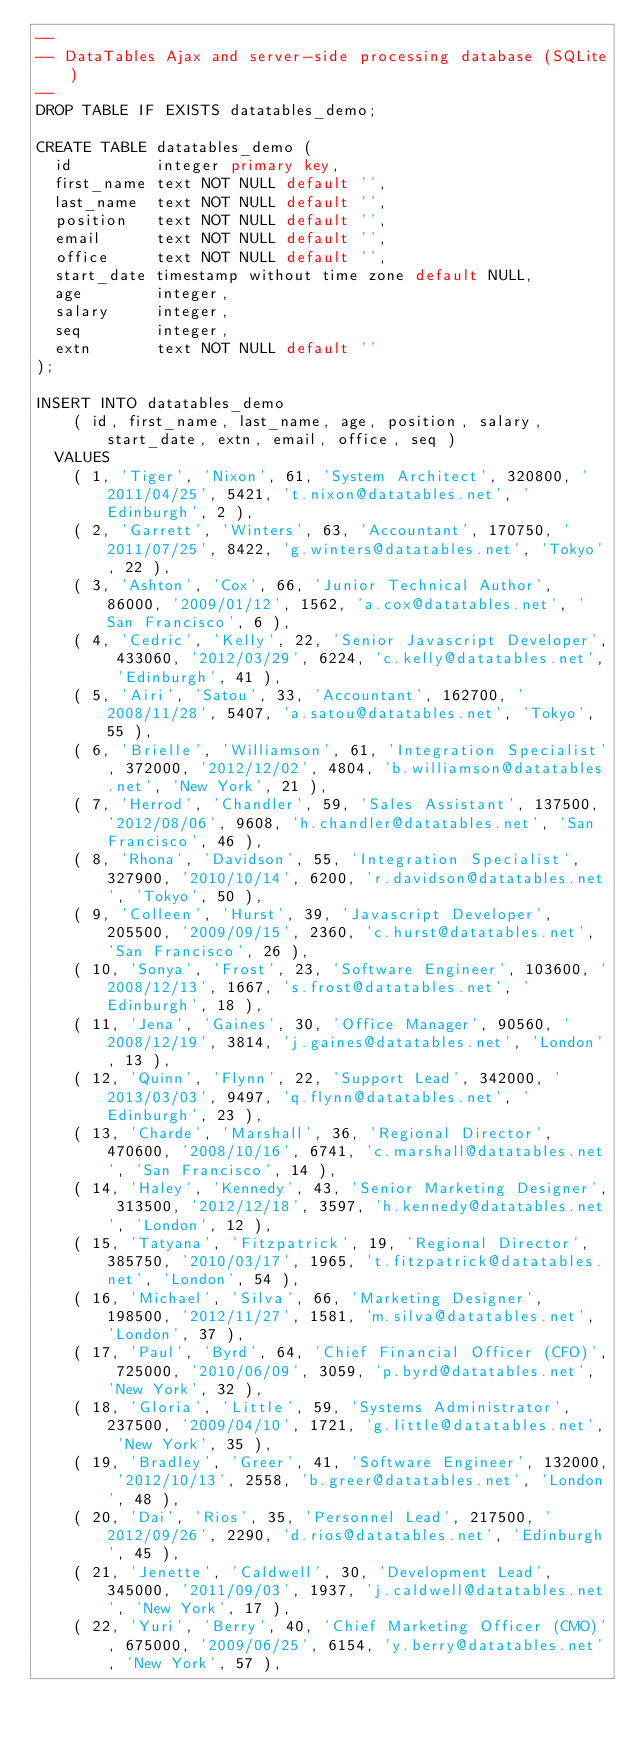<code> <loc_0><loc_0><loc_500><loc_500><_SQL_>--
-- DataTables Ajax and server-side processing database (SQLite)
--
DROP TABLE IF EXISTS datatables_demo;

CREATE TABLE datatables_demo (
	id         integer primary key,
	first_name text NOT NULL default '',
	last_name  text NOT NULL default '',
	position   text NOT NULL default '',
	email      text NOT NULL default '',
	office     text NOT NULL default '',
	start_date timestamp without time zone default NULL,
	age        integer,
	salary     integer,
	seq        integer,
	extn       text NOT NULL default ''
);

INSERT INTO datatables_demo
		( id, first_name, last_name, age, position, salary, start_date, extn, email, office, seq ) 
	VALUES
		( 1, 'Tiger', 'Nixon', 61, 'System Architect', 320800, '2011/04/25', 5421, 't.nixon@datatables.net', 'Edinburgh', 2 ),
		( 2, 'Garrett', 'Winters', 63, 'Accountant', 170750, '2011/07/25', 8422, 'g.winters@datatables.net', 'Tokyo', 22 ),
		( 3, 'Ashton', 'Cox', 66, 'Junior Technical Author', 86000, '2009/01/12', 1562, 'a.cox@datatables.net', 'San Francisco', 6 ),
		( 4, 'Cedric', 'Kelly', 22, 'Senior Javascript Developer', 433060, '2012/03/29', 6224, 'c.kelly@datatables.net', 'Edinburgh', 41 ),
		( 5, 'Airi', 'Satou', 33, 'Accountant', 162700, '2008/11/28', 5407, 'a.satou@datatables.net', 'Tokyo', 55 ),
		( 6, 'Brielle', 'Williamson', 61, 'Integration Specialist', 372000, '2012/12/02', 4804, 'b.williamson@datatables.net', 'New York', 21 ),
		( 7, 'Herrod', 'Chandler', 59, 'Sales Assistant', 137500, '2012/08/06', 9608, 'h.chandler@datatables.net', 'San Francisco', 46 ),
		( 8, 'Rhona', 'Davidson', 55, 'Integration Specialist', 327900, '2010/10/14', 6200, 'r.davidson@datatables.net', 'Tokyo', 50 ),
		( 9, 'Colleen', 'Hurst', 39, 'Javascript Developer', 205500, '2009/09/15', 2360, 'c.hurst@datatables.net', 'San Francisco', 26 ),
		( 10, 'Sonya', 'Frost', 23, 'Software Engineer', 103600, '2008/12/13', 1667, 's.frost@datatables.net', 'Edinburgh', 18 ),
		( 11, 'Jena', 'Gaines', 30, 'Office Manager', 90560, '2008/12/19', 3814, 'j.gaines@datatables.net', 'London', 13 ),
		( 12, 'Quinn', 'Flynn', 22, 'Support Lead', 342000, '2013/03/03', 9497, 'q.flynn@datatables.net', 'Edinburgh', 23 ),
		( 13, 'Charde', 'Marshall', 36, 'Regional Director', 470600, '2008/10/16', 6741, 'c.marshall@datatables.net', 'San Francisco', 14 ),
		( 14, 'Haley', 'Kennedy', 43, 'Senior Marketing Designer', 313500, '2012/12/18', 3597, 'h.kennedy@datatables.net', 'London', 12 ),
		( 15, 'Tatyana', 'Fitzpatrick', 19, 'Regional Director', 385750, '2010/03/17', 1965, 't.fitzpatrick@datatables.net', 'London', 54 ),
		( 16, 'Michael', 'Silva', 66, 'Marketing Designer', 198500, '2012/11/27', 1581, 'm.silva@datatables.net', 'London', 37 ),
		( 17, 'Paul', 'Byrd', 64, 'Chief Financial Officer (CFO)', 725000, '2010/06/09', 3059, 'p.byrd@datatables.net', 'New York', 32 ),
		( 18, 'Gloria', 'Little', 59, 'Systems Administrator', 237500, '2009/04/10', 1721, 'g.little@datatables.net', 'New York', 35 ),
		( 19, 'Bradley', 'Greer', 41, 'Software Engineer', 132000, '2012/10/13', 2558, 'b.greer@datatables.net', 'London', 48 ),
		( 20, 'Dai', 'Rios', 35, 'Personnel Lead', 217500, '2012/09/26', 2290, 'd.rios@datatables.net', 'Edinburgh', 45 ),
		( 21, 'Jenette', 'Caldwell', 30, 'Development Lead', 345000, '2011/09/03', 1937, 'j.caldwell@datatables.net', 'New York', 17 ),
		( 22, 'Yuri', 'Berry', 40, 'Chief Marketing Officer (CMO)', 675000, '2009/06/25', 6154, 'y.berry@datatables.net', 'New York', 57 ),</code> 